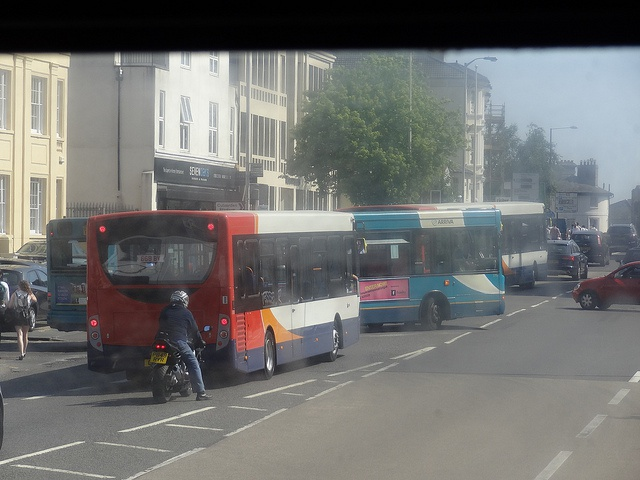Describe the objects in this image and their specific colors. I can see bus in black, gray, maroon, and lightgray tones, bus in black, gray, darkgray, and teal tones, bus in black, purple, and darkblue tones, bus in black, gray, darkgray, and darkblue tones, and car in black and gray tones in this image. 